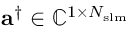<formula> <loc_0><loc_0><loc_500><loc_500>a ^ { \dag } \in \mathbb { C } ^ { 1 \times N _ { s l m } }</formula> 